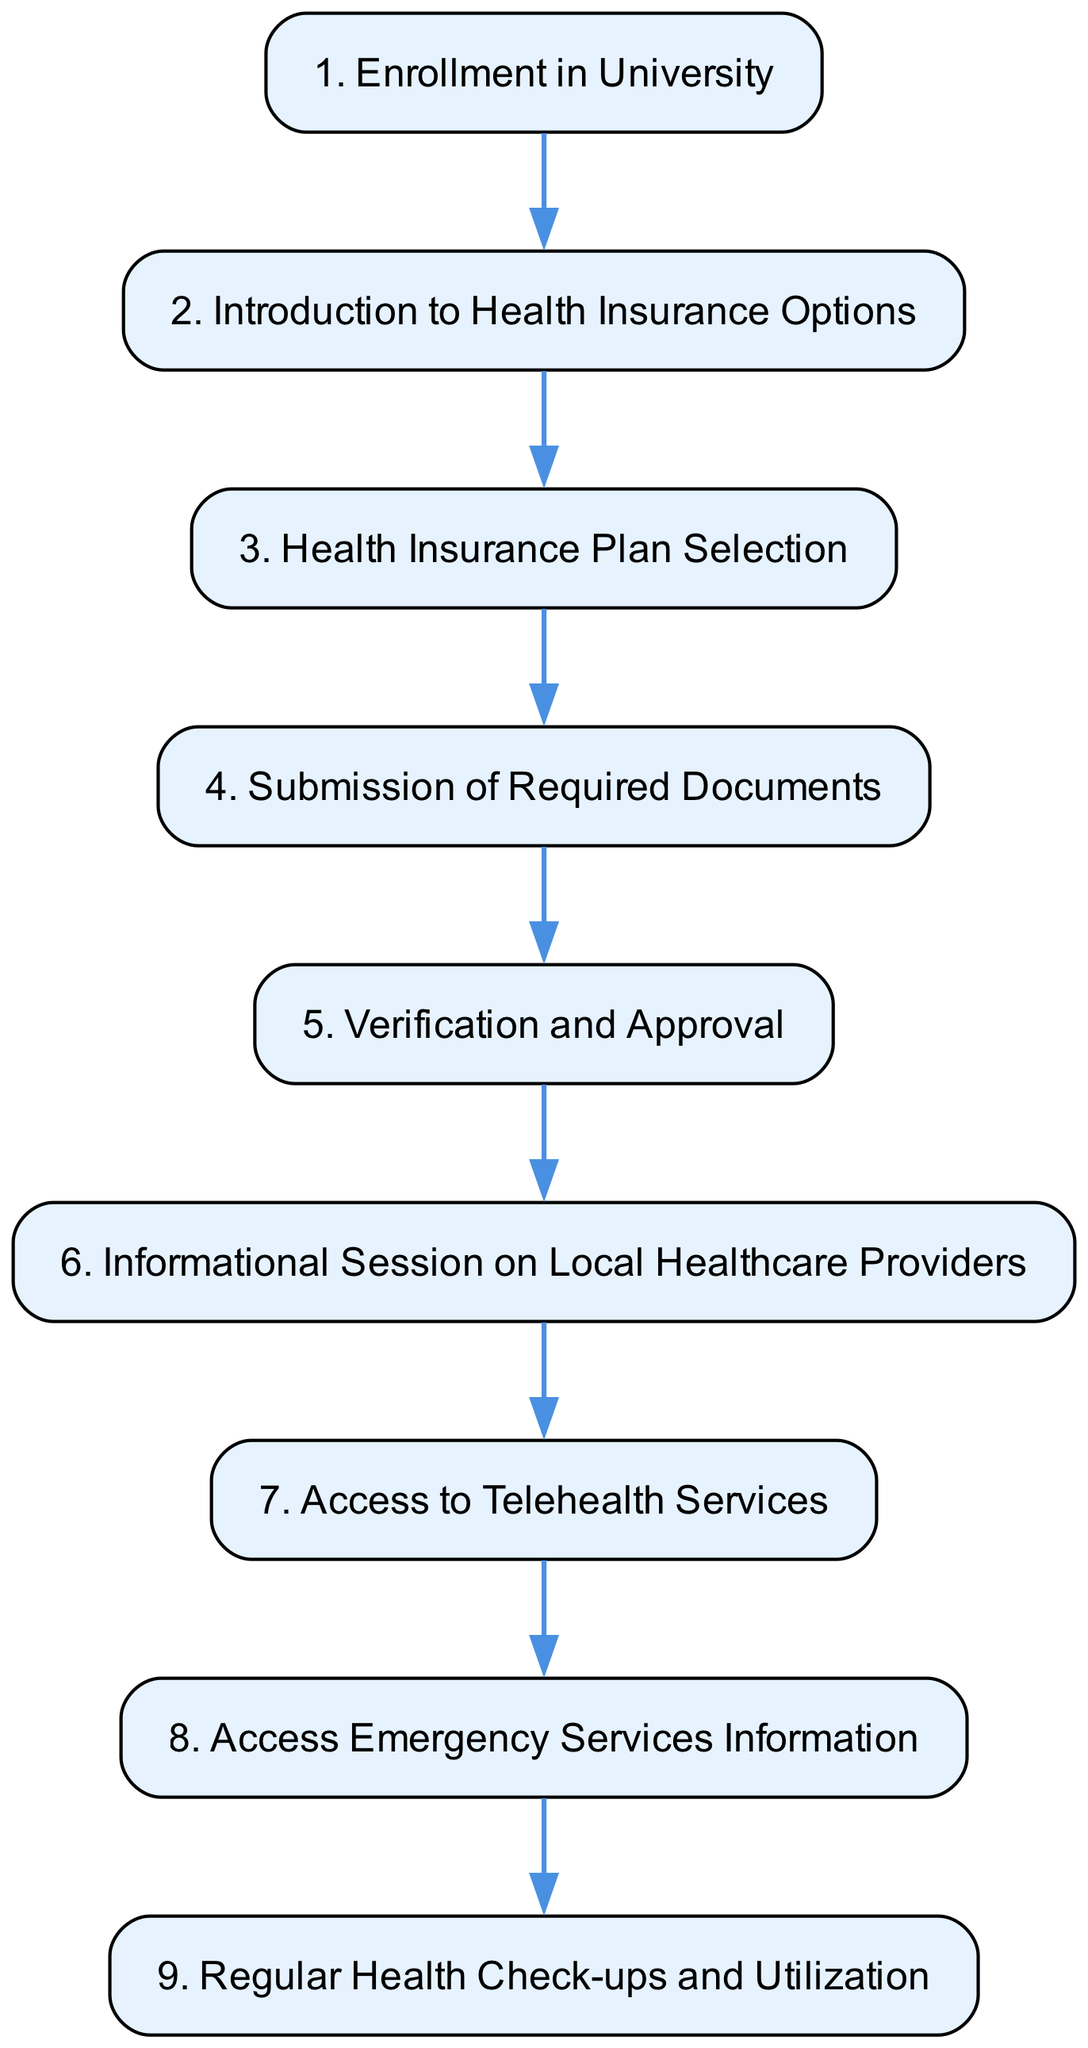What is the title of step 3? The title of step 3 is "Health Insurance Plan Selection," which can be found as the label for node step_3 in the diagram.
Answer: Health Insurance Plan Selection How many steps are in the pathway? There are 9 steps in the pathway, as indicated by the count of the pathway elements provided in the data structure.
Answer: 9 Which step follows "Submission of Required Documents"? "Verification and Approval" follows "Submission of Required Documents," and this is deduced by looking at the directed connection from step 4 to step 5 in the diagram.
Answer: Verification and Approval What step number is "Access Telehealth Services"? "Access Telehealth Services" is step 7, which can be identified by its position in the order of steps in the pathway.
Answer: 7 Which document must a student submit in step 4? The student must submit proof of health coverage in step 4, as mentioned in the description associated with "Submission of Required Documents."
Answer: Proof of health coverage What is the last step in the pathway? The last step in the pathway is "Regular Health Check-ups and Utilization," which corresponds to step 9 in the diagram, indicating that it is the final stage of the process.
Answer: Regular Health Check-ups and Utilization What type of services does the student gain access to in step 7? The student gains access to telehealth services in step 7, as specifically described in the title and description for this step.
Answer: Telehealth services What is the main action taken in step 5? The main action in step 5 is "Verification and Approval," which involves the university's health office verifying insurance details.
Answer: Verification and Approval What follows the "Introduction to Health Insurance Options"? Following the "Introduction to Health Insurance Options" is the "Health Insurance Plan Selection," showing a sequential flow from step 2 to step 3 in the pathway.
Answer: Health Insurance Plan Selection 